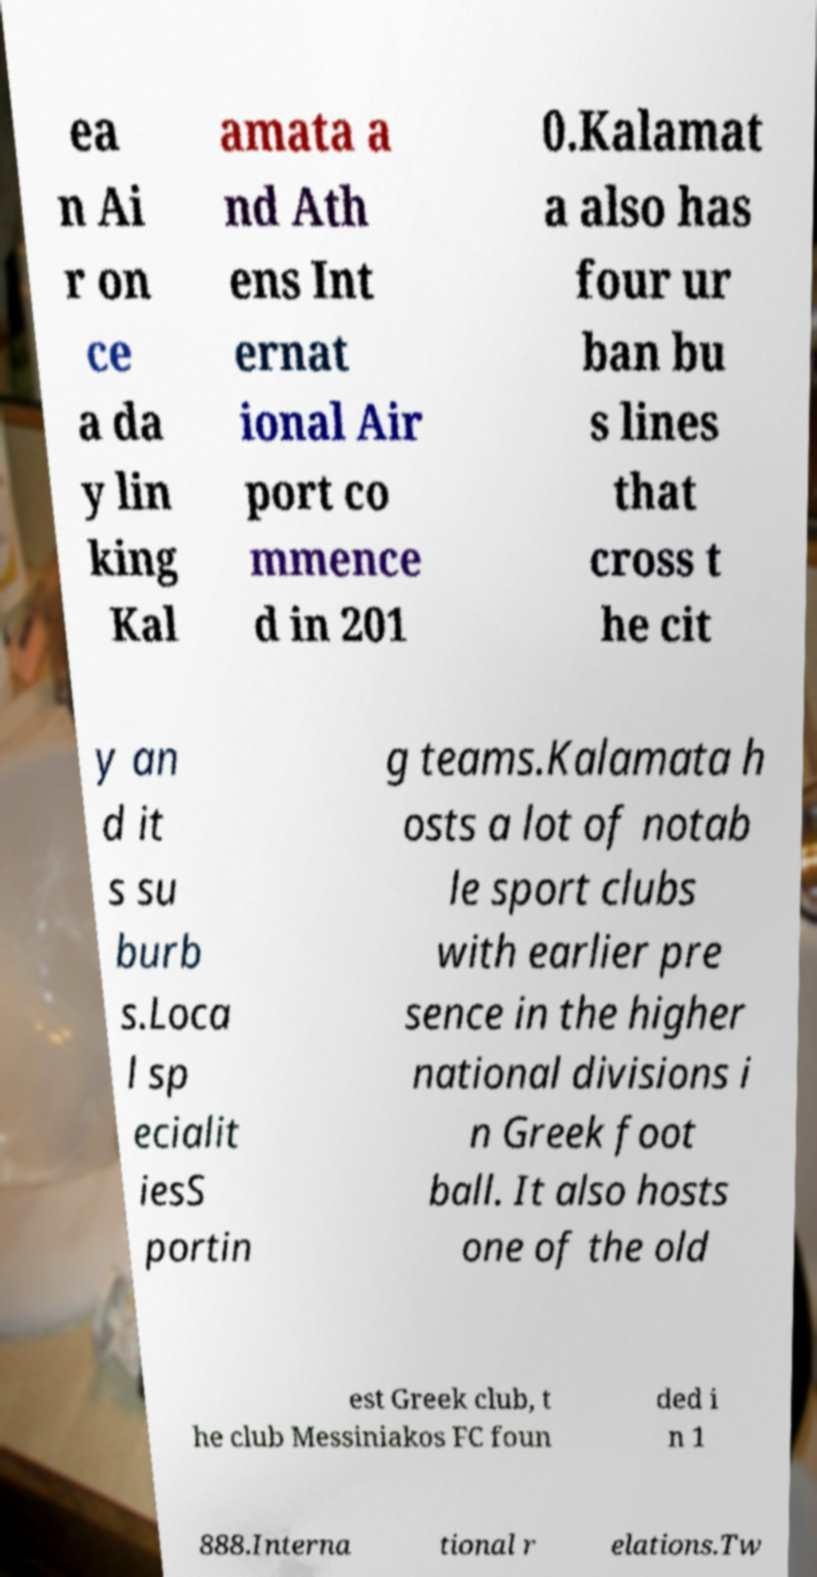There's text embedded in this image that I need extracted. Can you transcribe it verbatim? ea n Ai r on ce a da y lin king Kal amata a nd Ath ens Int ernat ional Air port co mmence d in 201 0.Kalamat a also has four ur ban bu s lines that cross t he cit y an d it s su burb s.Loca l sp ecialit iesS portin g teams.Kalamata h osts a lot of notab le sport clubs with earlier pre sence in the higher national divisions i n Greek foot ball. It also hosts one of the old est Greek club, t he club Messiniakos FC foun ded i n 1 888.Interna tional r elations.Tw 